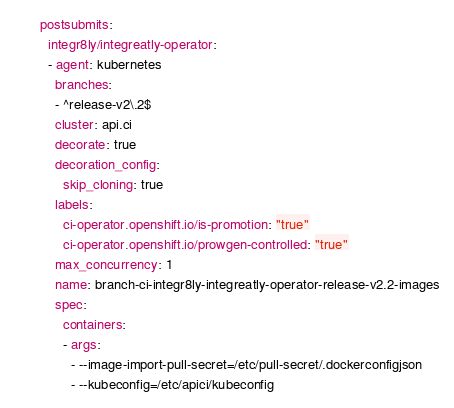Convert code to text. <code><loc_0><loc_0><loc_500><loc_500><_YAML_>postsubmits:
  integr8ly/integreatly-operator:
  - agent: kubernetes
    branches:
    - ^release-v2\.2$
    cluster: api.ci
    decorate: true
    decoration_config:
      skip_cloning: true
    labels:
      ci-operator.openshift.io/is-promotion: "true"
      ci-operator.openshift.io/prowgen-controlled: "true"
    max_concurrency: 1
    name: branch-ci-integr8ly-integreatly-operator-release-v2.2-images
    spec:
      containers:
      - args:
        - --image-import-pull-secret=/etc/pull-secret/.dockerconfigjson
        - --kubeconfig=/etc/apici/kubeconfig</code> 